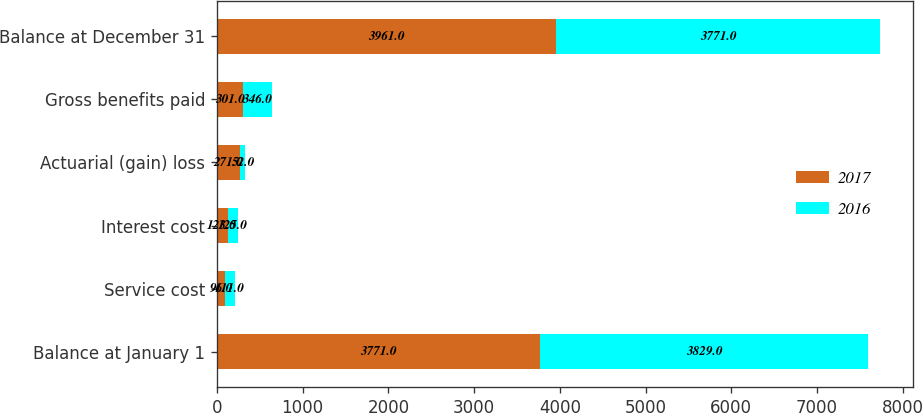Convert chart. <chart><loc_0><loc_0><loc_500><loc_500><stacked_bar_chart><ecel><fcel>Balance at January 1<fcel>Service cost<fcel>Interest cost<fcel>Actuarial (gain) loss<fcel>Gross benefits paid<fcel>Balance at December 31<nl><fcel>2017<fcel>3771<fcel>96<fcel>123<fcel>271<fcel>301<fcel>3961<nl><fcel>2016<fcel>3829<fcel>111<fcel>125<fcel>52<fcel>346<fcel>3771<nl></chart> 